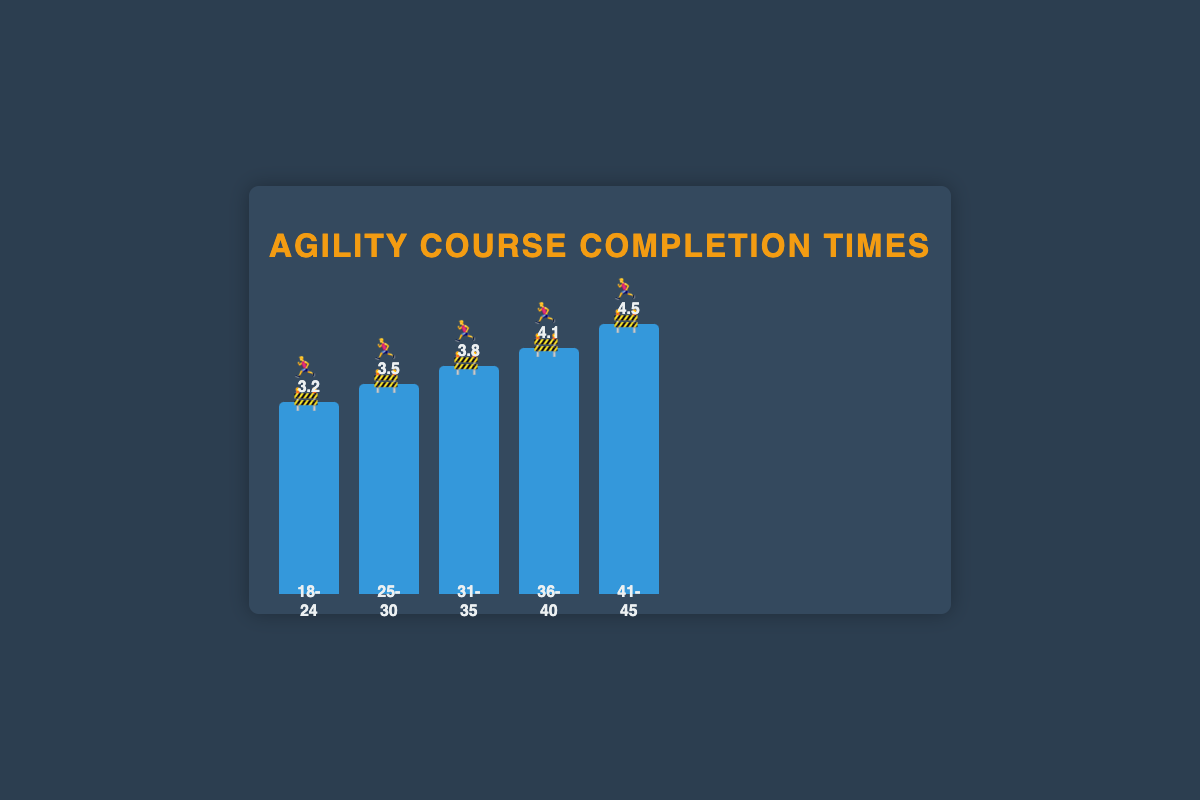Which age group has the fastest agility course completion time? Look for the bar with the lowest value in completion time. The 18-24 age group has the bar labeled with 3.2 minutes, the shortest time.
Answer: 18-24 What's the difference in completion time between the 18-24 and 41-45 age groups? Identify the bars for both the 18-24 and 41-45 age groups. Subtract the lower time (3.2 minutes) from the higher time (4.5 minutes).
Answer: 1.3 minutes Compare the average completion times between the 25-30 and 36-40 age groups. Which age group is faster? Examine the bars for the 25-30 and 36-40 age groups. The 25-30 age group has a completion time of 3.5 minutes, while the 36-40 age group has a completion time of 4.1 minutes.
Answer: 25-30 What is the average completion time across all age groups? Add all completion times (3.2 + 3.5 + 3.8 + 4.1 + 4.5) and divide by the number of age groups (5). The sum is 19.1, dividing by 5 gives 3.82 minutes.
Answer: 3.82 minutes How does the completion time change as age increases from 18-24 to 41-45? Observe the trend across the bars from left to right. The completion time increases as the age group increases from 18-24 (3.2) to 41-45 (4.5).
Answer: Increases Which age group has the completion time closest to 4 minutes? Identify the bar whose value is nearest to 4 minutes. The 36-40 age group has a completion time of 4.1 minutes, which is the closest.
Answer: 36-40 How much slower is the 36-40 age group compared to the 31-35 age group? Look at the completion times for both groups. Subtract 3.8 (31-35) from 4.1 (36-40).
Answer: 0.3 minutes Arrange the age groups in ascending order of their average completion times. List the age groups based on their completion times from the smallest to the largest: 18-24 (3.2), 25-30 (3.5), 31-35 (3.8), 36-40 (4.1), 41-45 (4.5).
Answer: 18-24, 25-30, 31-35, 36-40, 41-45 What symbols are used to represent the agility course completion times in the chart? Each bar in the chart has emojis inside the bar. The emoji used is a combination of a runner and an obstacle: 🏃‍♂️🚧.
Answer: 🏃‍♂️🚧 